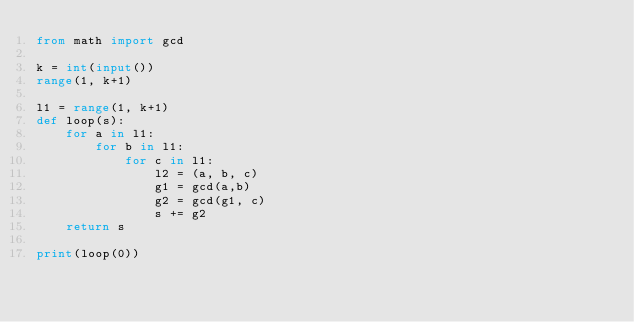Convert code to text. <code><loc_0><loc_0><loc_500><loc_500><_Python_>from math import gcd

k = int(input())
range(1, k+1)

l1 = range(1, k+1)
def loop(s):
    for a in l1:
        for b in l1:
            for c in l1:
                l2 = (a, b, c)
                g1 = gcd(a,b)
                g2 = gcd(g1, c)
                s += g2
    return s

print(loop(0))</code> 